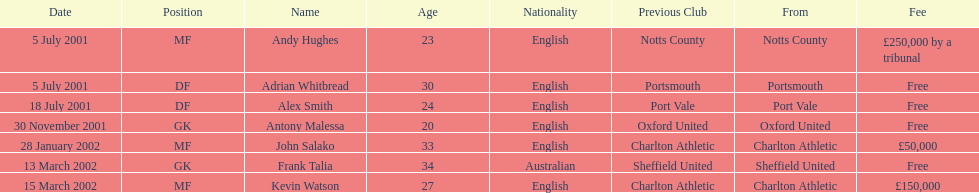Whos name is listed last on the chart? Kevin Watson. 